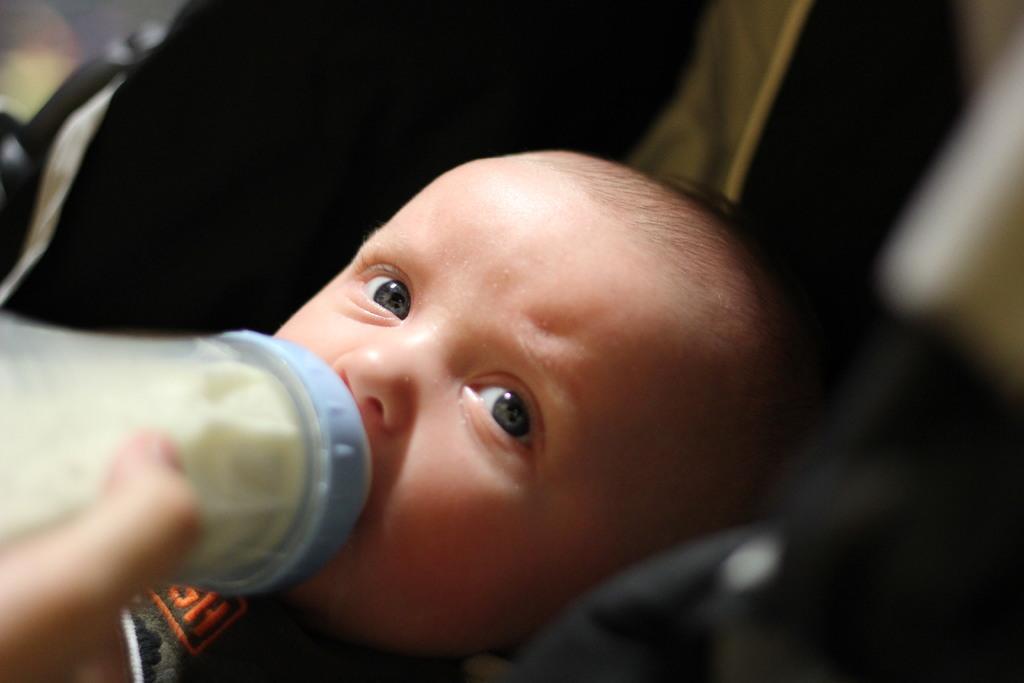How would you summarize this image in a sentence or two? In this picture we can see small baby drinking milk from the bottle and looking to the camera. Behind there is a dark background. 